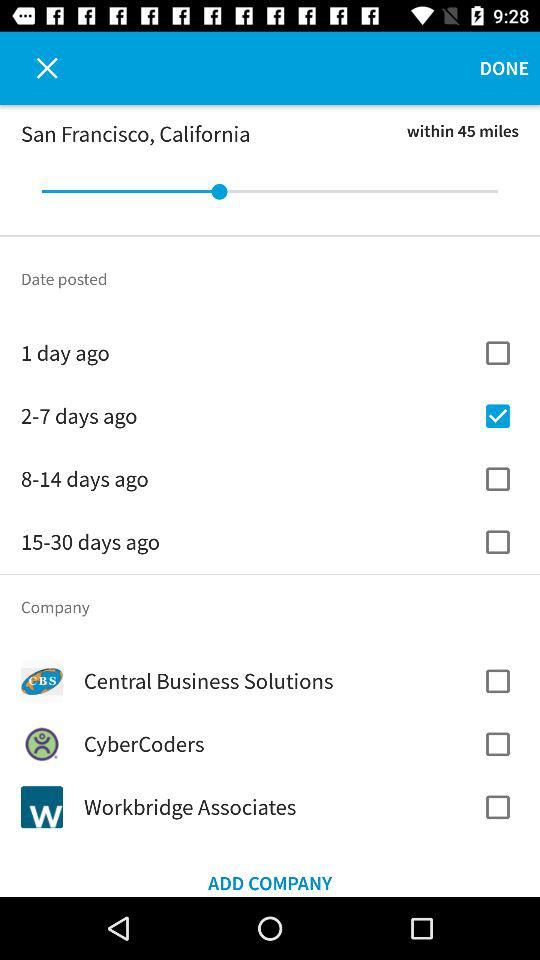What is the state name? The state name is California. 